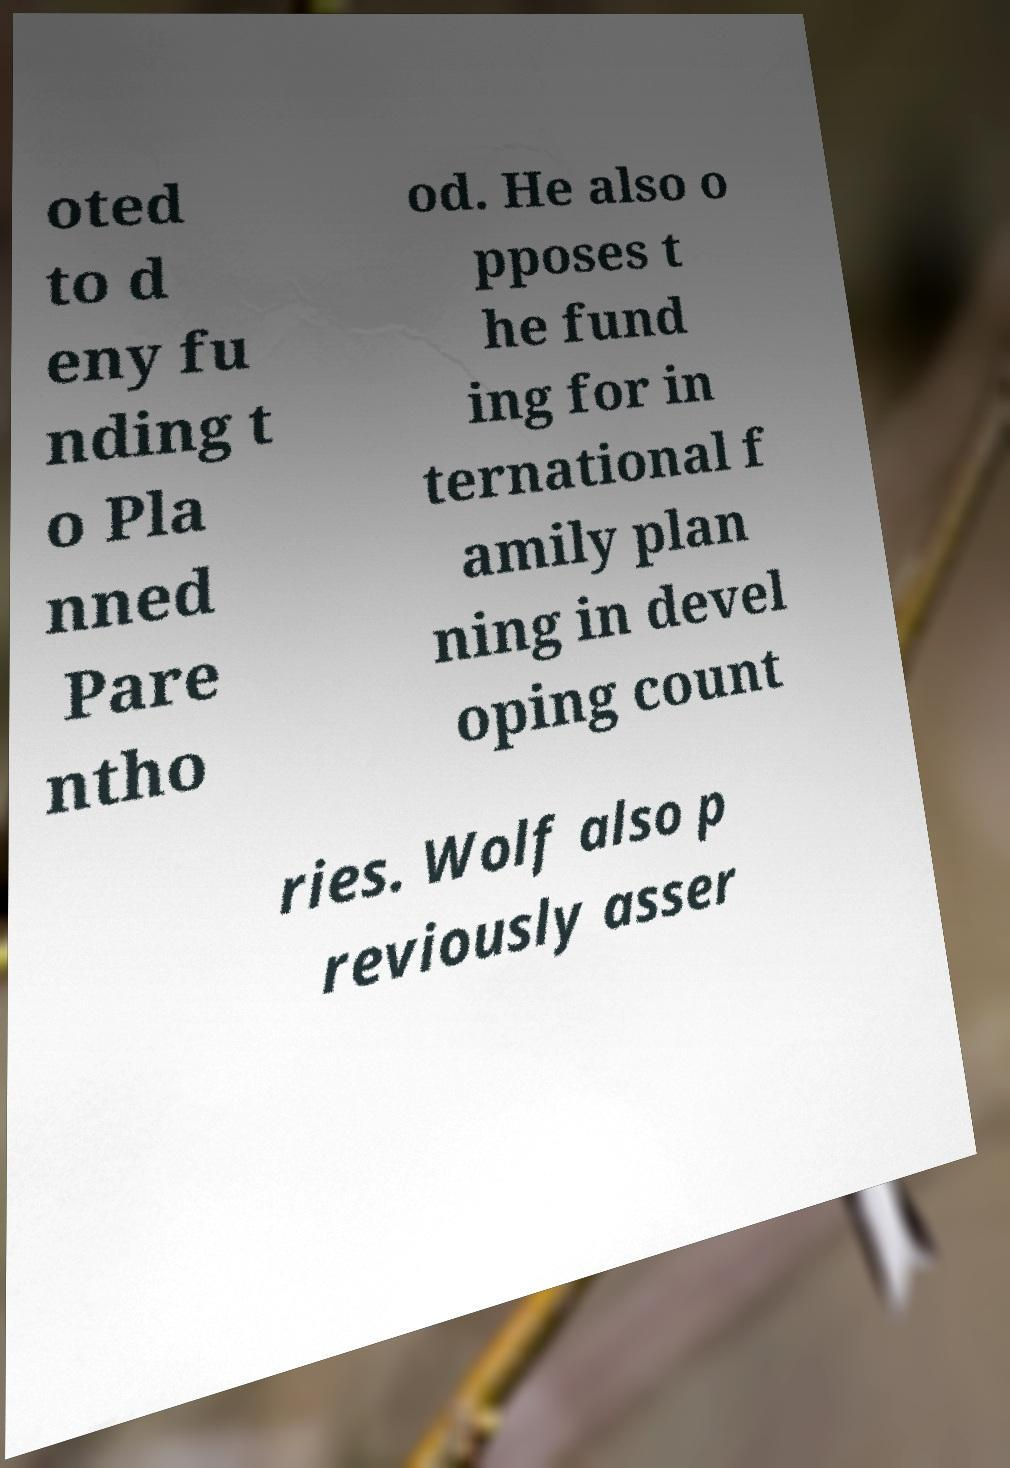Please identify and transcribe the text found in this image. oted to d eny fu nding t o Pla nned Pare ntho od. He also o pposes t he fund ing for in ternational f amily plan ning in devel oping count ries. Wolf also p reviously asser 